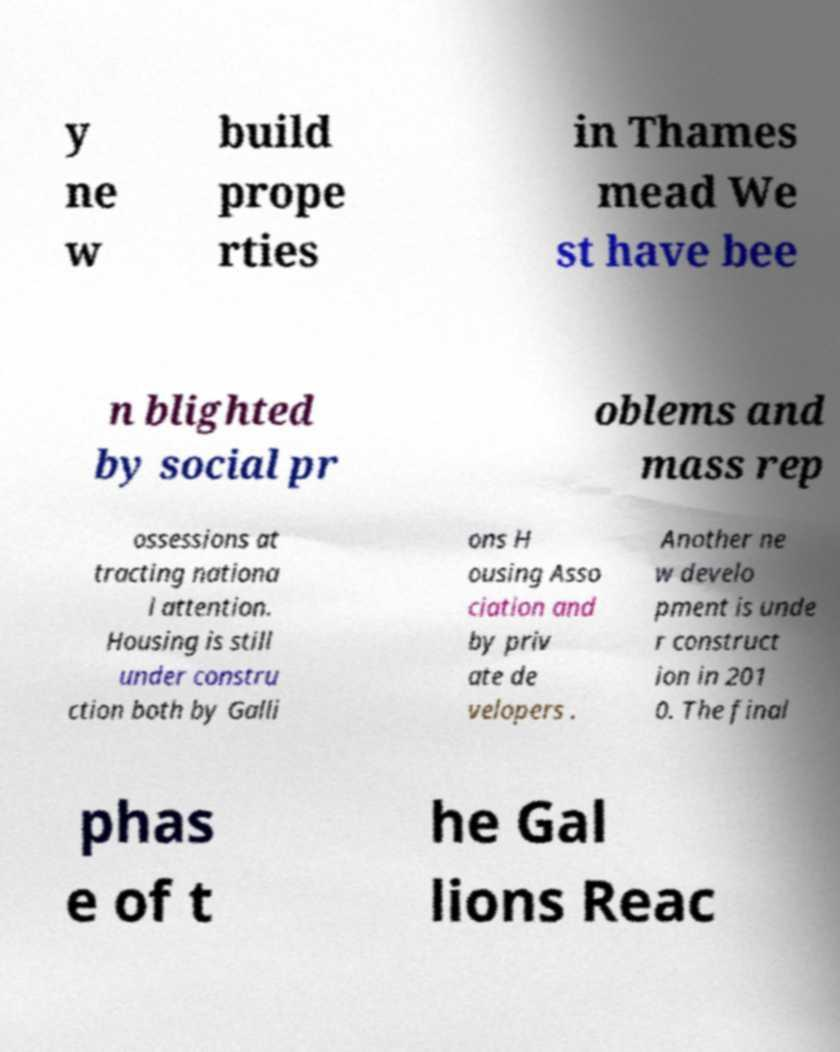Could you assist in decoding the text presented in this image and type it out clearly? y ne w build prope rties in Thames mead We st have bee n blighted by social pr oblems and mass rep ossessions at tracting nationa l attention. Housing is still under constru ction both by Galli ons H ousing Asso ciation and by priv ate de velopers . Another ne w develo pment is unde r construct ion in 201 0. The final phas e of t he Gal lions Reac 